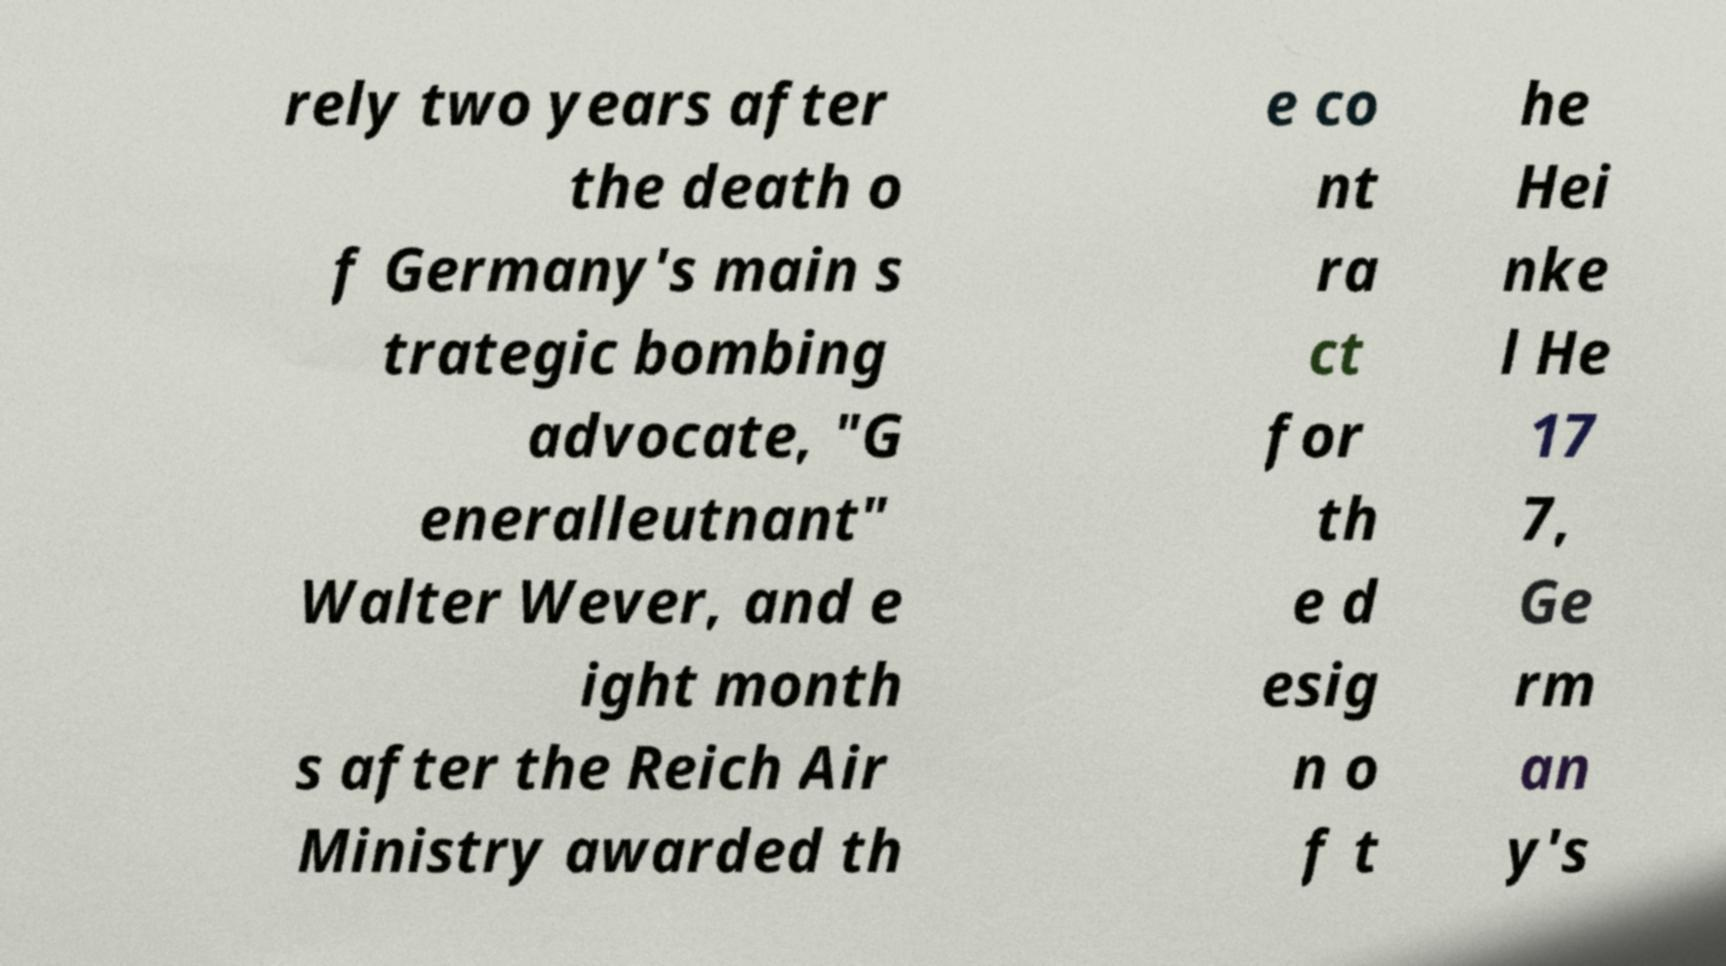Can you read and provide the text displayed in the image?This photo seems to have some interesting text. Can you extract and type it out for me? rely two years after the death o f Germany's main s trategic bombing advocate, "G eneralleutnant" Walter Wever, and e ight month s after the Reich Air Ministry awarded th e co nt ra ct for th e d esig n o f t he Hei nke l He 17 7, Ge rm an y's 